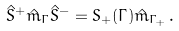<formula> <loc_0><loc_0><loc_500><loc_500>\hat { S } ^ { + } \hat { m } _ { \Gamma } \hat { S } ^ { - } = S _ { + } ( \Gamma ) \hat { m } _ { \Gamma _ { + } } \, .</formula> 